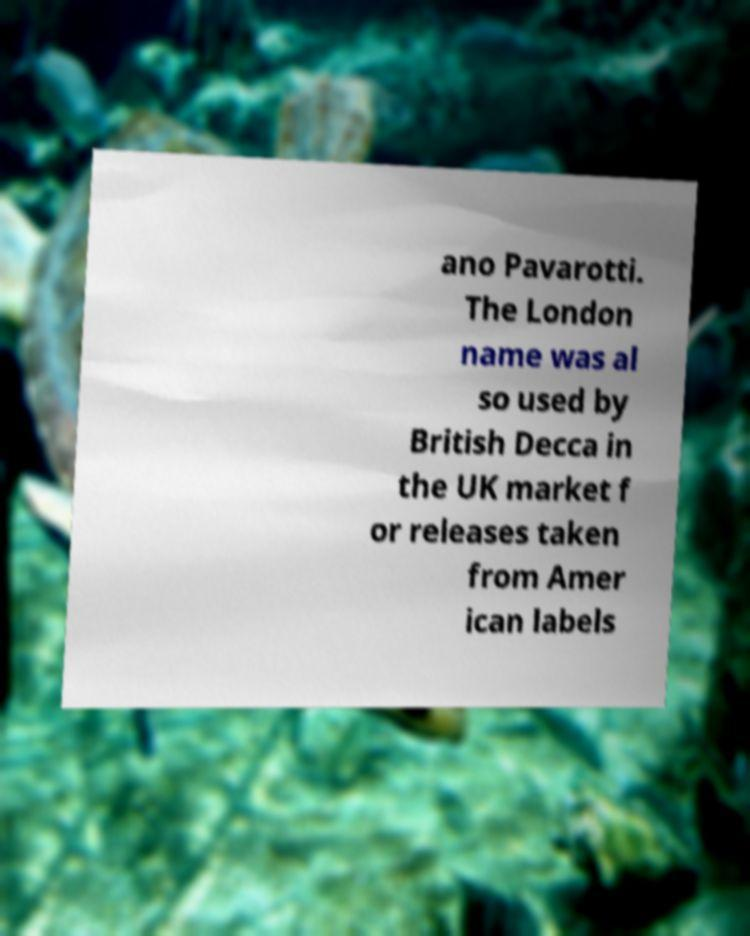Please identify and transcribe the text found in this image. ano Pavarotti. The London name was al so used by British Decca in the UK market f or releases taken from Amer ican labels 